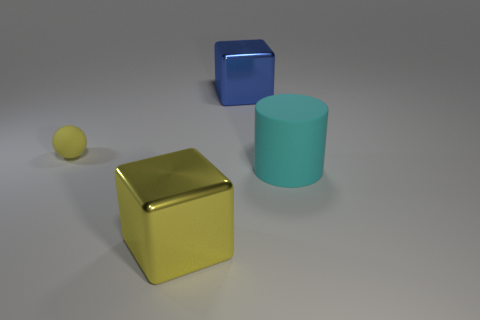Add 1 tiny blue metallic blocks. How many objects exist? 5 Subtract all cylinders. How many objects are left? 3 Add 2 big yellow metal things. How many big yellow metal things exist? 3 Subtract 1 blue cubes. How many objects are left? 3 Subtract all tiny cyan rubber blocks. Subtract all blocks. How many objects are left? 2 Add 1 rubber cylinders. How many rubber cylinders are left? 2 